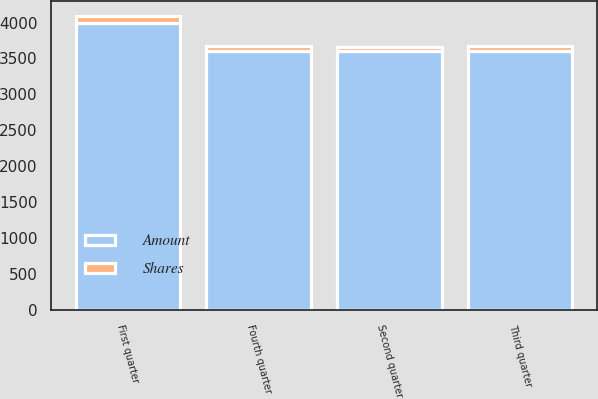<chart> <loc_0><loc_0><loc_500><loc_500><stacked_bar_chart><ecel><fcel>First quarter<fcel>Second quarter<fcel>Third quarter<fcel>Fourth quarter<nl><fcel>Shares<fcel>89<fcel>66<fcel>69<fcel>70<nl><fcel>Amount<fcel>4000<fcel>3600<fcel>3600<fcel>3600<nl></chart> 